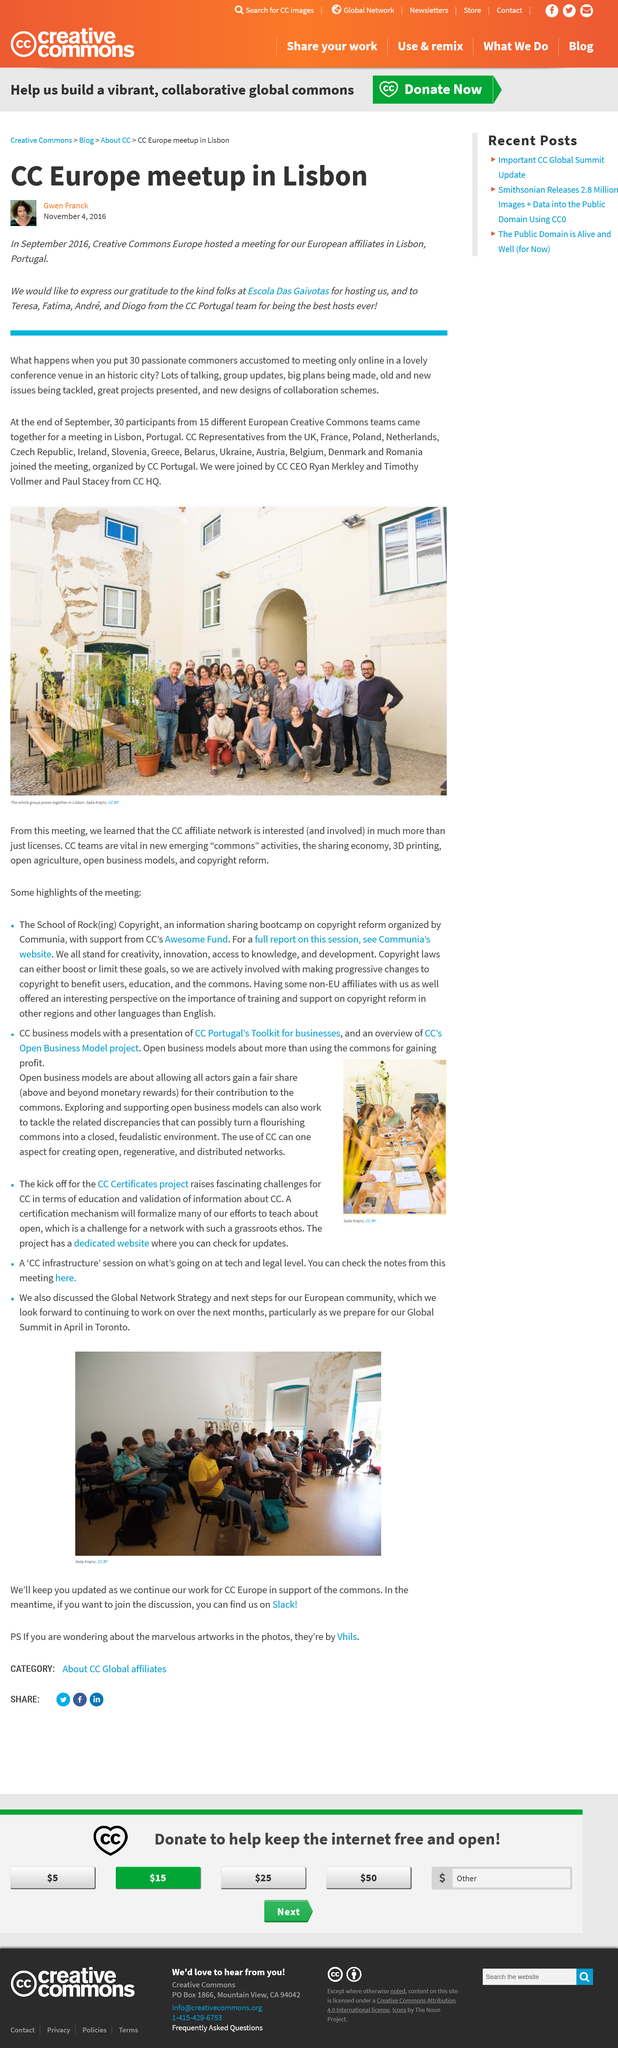Identify some key points in this picture. There were 30 participants at the meeting. The meetup took place in Lisbon, Portugal. The Europe meetup took place in September 2016. Fifteen different European Creative Commons teams gathered for the meeting. The photograph was taken in Portugal. 